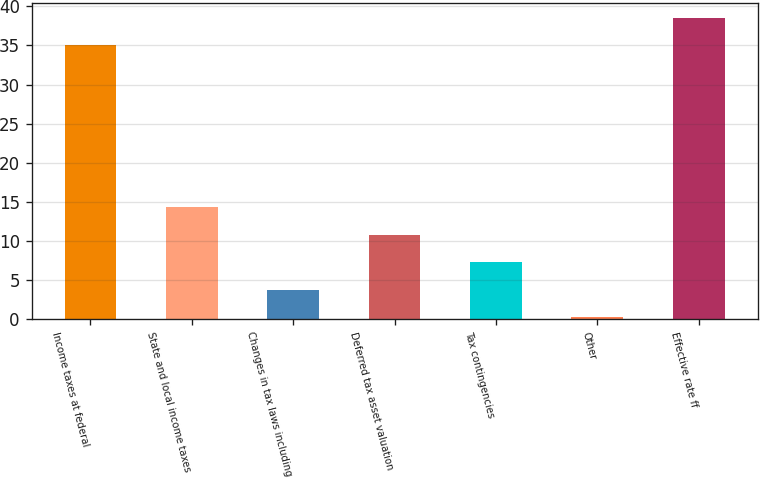Convert chart to OTSL. <chart><loc_0><loc_0><loc_500><loc_500><bar_chart><fcel>Income taxes at federal<fcel>State and local income taxes<fcel>Changes in tax laws including<fcel>Deferred tax asset valuation<fcel>Tax contingencies<fcel>Other<fcel>Effective rate ff<nl><fcel>35<fcel>14.32<fcel>3.73<fcel>10.79<fcel>7.26<fcel>0.2<fcel>38.53<nl></chart> 